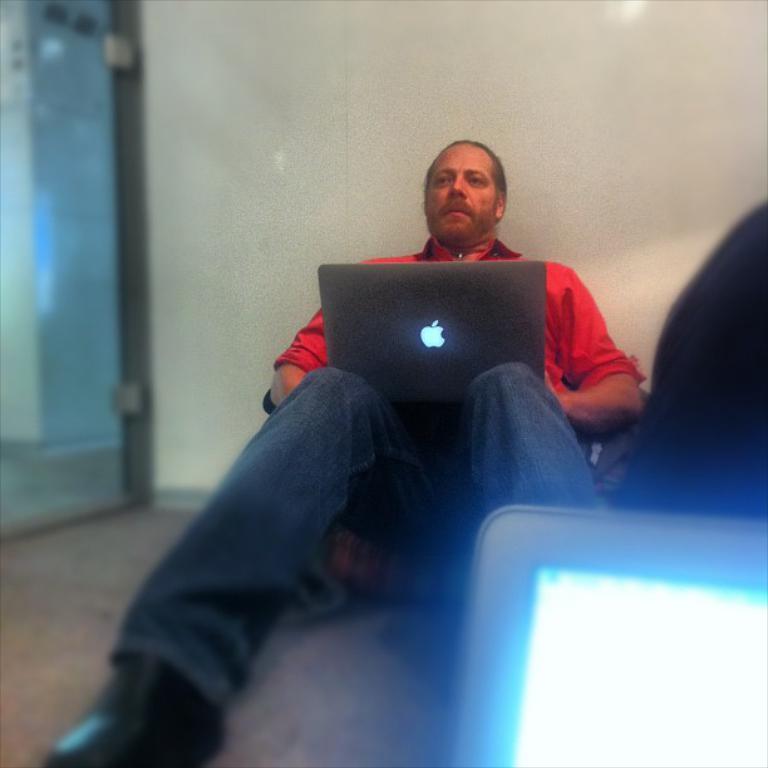Please provide a concise description of this image. In this picture a man carrying a laptop and sitting leaning to the wall. 